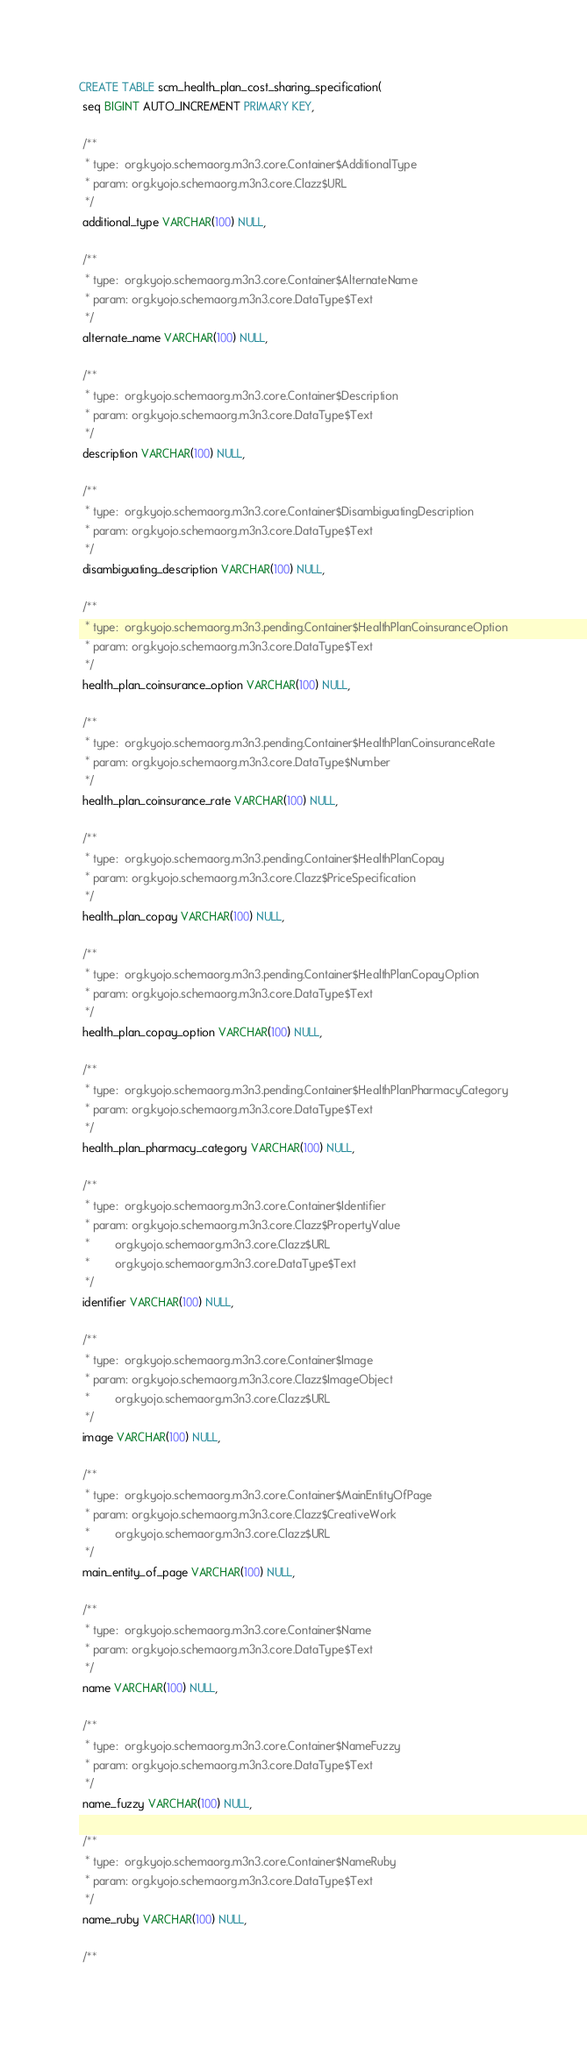<code> <loc_0><loc_0><loc_500><loc_500><_SQL_>CREATE TABLE scm_health_plan_cost_sharing_specification(
 seq BIGINT AUTO_INCREMENT PRIMARY KEY,

 /**
  * type:  org.kyojo.schemaorg.m3n3.core.Container$AdditionalType
  * param: org.kyojo.schemaorg.m3n3.core.Clazz$URL
  */
 additional_type VARCHAR(100) NULL,

 /**
  * type:  org.kyojo.schemaorg.m3n3.core.Container$AlternateName
  * param: org.kyojo.schemaorg.m3n3.core.DataType$Text
  */
 alternate_name VARCHAR(100) NULL,

 /**
  * type:  org.kyojo.schemaorg.m3n3.core.Container$Description
  * param: org.kyojo.schemaorg.m3n3.core.DataType$Text
  */
 description VARCHAR(100) NULL,

 /**
  * type:  org.kyojo.schemaorg.m3n3.core.Container$DisambiguatingDescription
  * param: org.kyojo.schemaorg.m3n3.core.DataType$Text
  */
 disambiguating_description VARCHAR(100) NULL,

 /**
  * type:  org.kyojo.schemaorg.m3n3.pending.Container$HealthPlanCoinsuranceOption
  * param: org.kyojo.schemaorg.m3n3.core.DataType$Text
  */
 health_plan_coinsurance_option VARCHAR(100) NULL,

 /**
  * type:  org.kyojo.schemaorg.m3n3.pending.Container$HealthPlanCoinsuranceRate
  * param: org.kyojo.schemaorg.m3n3.core.DataType$Number
  */
 health_plan_coinsurance_rate VARCHAR(100) NULL,

 /**
  * type:  org.kyojo.schemaorg.m3n3.pending.Container$HealthPlanCopay
  * param: org.kyojo.schemaorg.m3n3.core.Clazz$PriceSpecification
  */
 health_plan_copay VARCHAR(100) NULL,

 /**
  * type:  org.kyojo.schemaorg.m3n3.pending.Container$HealthPlanCopayOption
  * param: org.kyojo.schemaorg.m3n3.core.DataType$Text
  */
 health_plan_copay_option VARCHAR(100) NULL,

 /**
  * type:  org.kyojo.schemaorg.m3n3.pending.Container$HealthPlanPharmacyCategory
  * param: org.kyojo.schemaorg.m3n3.core.DataType$Text
  */
 health_plan_pharmacy_category VARCHAR(100) NULL,

 /**
  * type:  org.kyojo.schemaorg.m3n3.core.Container$Identifier
  * param: org.kyojo.schemaorg.m3n3.core.Clazz$PropertyValue
  *        org.kyojo.schemaorg.m3n3.core.Clazz$URL
  *        org.kyojo.schemaorg.m3n3.core.DataType$Text
  */
 identifier VARCHAR(100) NULL,

 /**
  * type:  org.kyojo.schemaorg.m3n3.core.Container$Image
  * param: org.kyojo.schemaorg.m3n3.core.Clazz$ImageObject
  *        org.kyojo.schemaorg.m3n3.core.Clazz$URL
  */
 image VARCHAR(100) NULL,

 /**
  * type:  org.kyojo.schemaorg.m3n3.core.Container$MainEntityOfPage
  * param: org.kyojo.schemaorg.m3n3.core.Clazz$CreativeWork
  *        org.kyojo.schemaorg.m3n3.core.Clazz$URL
  */
 main_entity_of_page VARCHAR(100) NULL,

 /**
  * type:  org.kyojo.schemaorg.m3n3.core.Container$Name
  * param: org.kyojo.schemaorg.m3n3.core.DataType$Text
  */
 name VARCHAR(100) NULL,

 /**
  * type:  org.kyojo.schemaorg.m3n3.core.Container$NameFuzzy
  * param: org.kyojo.schemaorg.m3n3.core.DataType$Text
  */
 name_fuzzy VARCHAR(100) NULL,

 /**
  * type:  org.kyojo.schemaorg.m3n3.core.Container$NameRuby
  * param: org.kyojo.schemaorg.m3n3.core.DataType$Text
  */
 name_ruby VARCHAR(100) NULL,

 /**</code> 